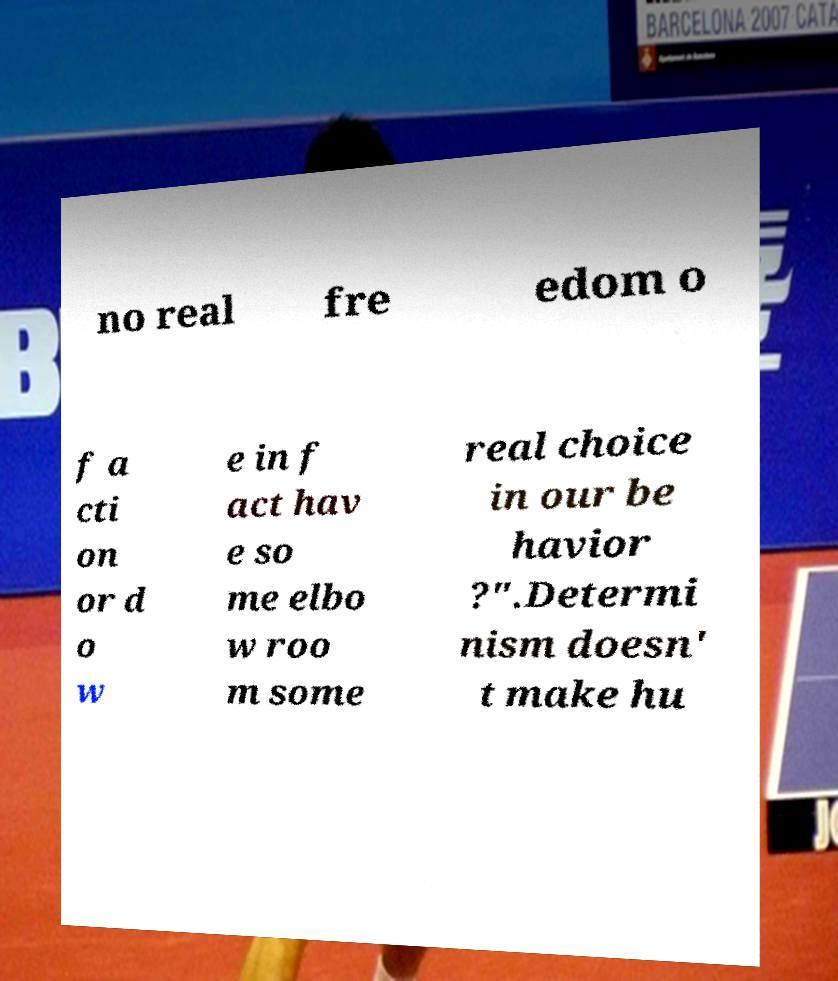Can you accurately transcribe the text from the provided image for me? no real fre edom o f a cti on or d o w e in f act hav e so me elbo w roo m some real choice in our be havior ?".Determi nism doesn' t make hu 